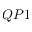Convert formula to latex. <formula><loc_0><loc_0><loc_500><loc_500>Q P 1</formula> 